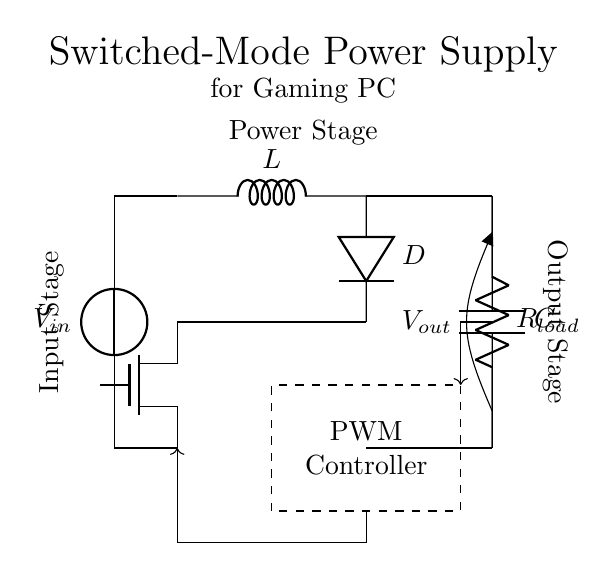What is the input voltage of the circuit? The input voltage is represented by the voltage source labeled $V_{in}$ in the circuit diagram. It is the first component from the left, indicating the voltage fed into the circuit.
Answer: Vin What type of regulator is shown in the circuit? The circuit diagram depicts a switched-mode power supply (SMPS) regulator, which is evident from the presence of a MOSFET, inductor, and PWM controller all forming part of the power conversion process.
Answer: Switched-mode power supply What component is responsible for energy storage in this circuit? The inductor labeled $L$ is the component responsible for storing energy temporarily in this circuit, which is characteristic of switched-mode power supplies to smooth out the output voltage.
Answer: L What does the diode do in this circuit? The diode labeled $D$ allows current to flow in one direction, preventing backflow when the switch (MOSFET) is off, ensuring that stored energy in the inductor can be transferred to the output capacitor and load.
Answer: Prevents backflow What is the role of the PWM controller? The PWM controller regulates the output voltage by adjusting the duty cycle of the switching signal to the MOSFET, thus controlling the amount of energy transferred to the output stage.
Answer: Regulates output voltage What is the relationship between output voltage and load resistance? In this circuit, the output voltage ($V_{out}$) is influenced by the load resistance ($R_{load}$) because according to Ohm's law, an increase in load resistance typically results in a higher voltage drop across the resistor, affecting the overall output voltage.
Answer: Influences output voltage 